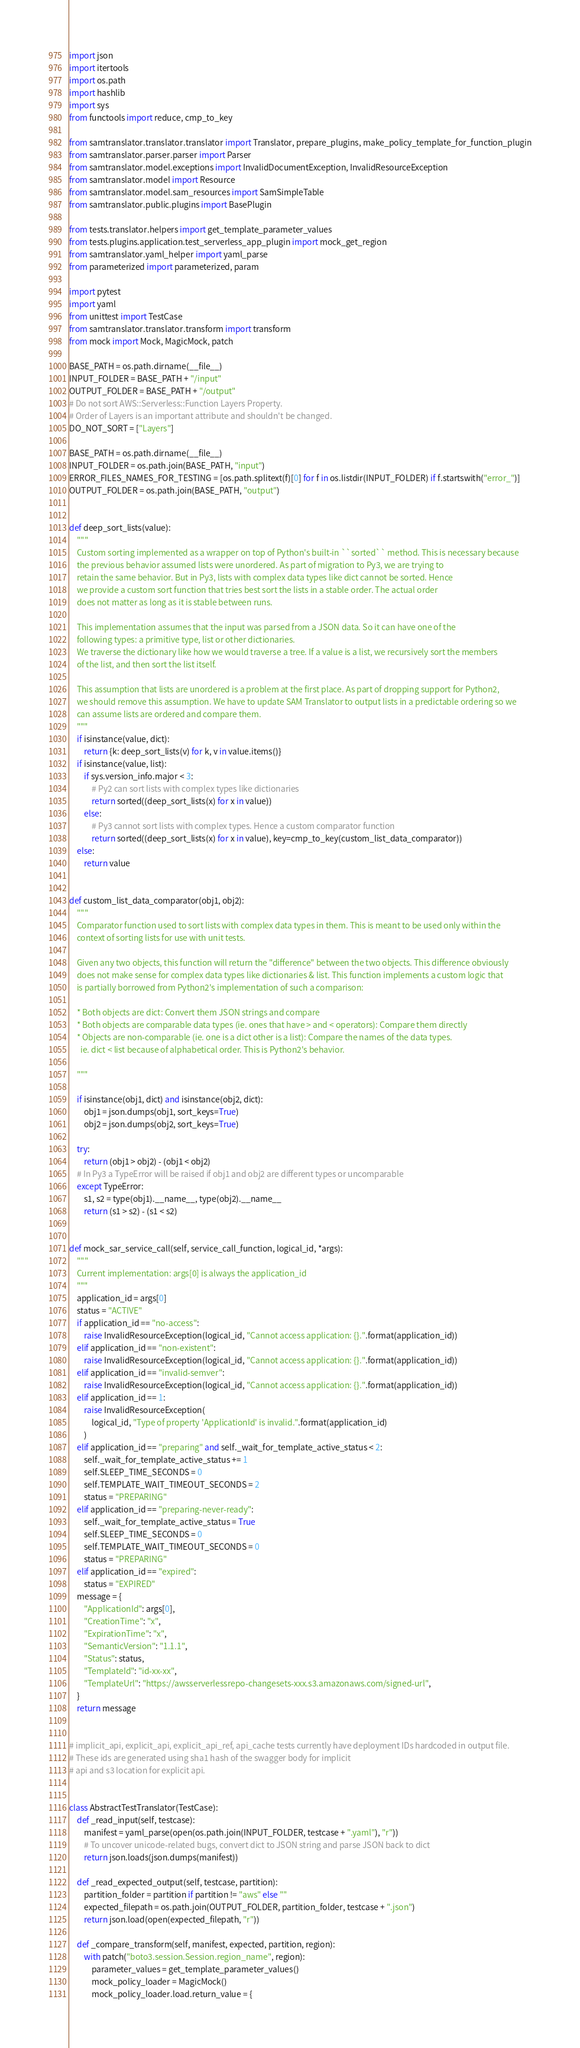<code> <loc_0><loc_0><loc_500><loc_500><_Python_>import json
import itertools
import os.path
import hashlib
import sys
from functools import reduce, cmp_to_key

from samtranslator.translator.translator import Translator, prepare_plugins, make_policy_template_for_function_plugin
from samtranslator.parser.parser import Parser
from samtranslator.model.exceptions import InvalidDocumentException, InvalidResourceException
from samtranslator.model import Resource
from samtranslator.model.sam_resources import SamSimpleTable
from samtranslator.public.plugins import BasePlugin

from tests.translator.helpers import get_template_parameter_values
from tests.plugins.application.test_serverless_app_plugin import mock_get_region
from samtranslator.yaml_helper import yaml_parse
from parameterized import parameterized, param

import pytest
import yaml
from unittest import TestCase
from samtranslator.translator.transform import transform
from mock import Mock, MagicMock, patch

BASE_PATH = os.path.dirname(__file__)
INPUT_FOLDER = BASE_PATH + "/input"
OUTPUT_FOLDER = BASE_PATH + "/output"
# Do not sort AWS::Serverless::Function Layers Property.
# Order of Layers is an important attribute and shouldn't be changed.
DO_NOT_SORT = ["Layers"]

BASE_PATH = os.path.dirname(__file__)
INPUT_FOLDER = os.path.join(BASE_PATH, "input")
ERROR_FILES_NAMES_FOR_TESTING = [os.path.splitext(f)[0] for f in os.listdir(INPUT_FOLDER) if f.startswith("error_")]
OUTPUT_FOLDER = os.path.join(BASE_PATH, "output")


def deep_sort_lists(value):
    """
    Custom sorting implemented as a wrapper on top of Python's built-in ``sorted`` method. This is necessary because
    the previous behavior assumed lists were unordered. As part of migration to Py3, we are trying to
    retain the same behavior. But in Py3, lists with complex data types like dict cannot be sorted. Hence
    we provide a custom sort function that tries best sort the lists in a stable order. The actual order
    does not matter as long as it is stable between runs.

    This implementation assumes that the input was parsed from a JSON data. So it can have one of the
    following types: a primitive type, list or other dictionaries.
    We traverse the dictionary like how we would traverse a tree. If a value is a list, we recursively sort the members
    of the list, and then sort the list itself.

    This assumption that lists are unordered is a problem at the first place. As part of dropping support for Python2,
    we should remove this assumption. We have to update SAM Translator to output lists in a predictable ordering so we
    can assume lists are ordered and compare them.
    """
    if isinstance(value, dict):
        return {k: deep_sort_lists(v) for k, v in value.items()}
    if isinstance(value, list):
        if sys.version_info.major < 3:
            # Py2 can sort lists with complex types like dictionaries
            return sorted((deep_sort_lists(x) for x in value))
        else:
            # Py3 cannot sort lists with complex types. Hence a custom comparator function
            return sorted((deep_sort_lists(x) for x in value), key=cmp_to_key(custom_list_data_comparator))
    else:
        return value


def custom_list_data_comparator(obj1, obj2):
    """
    Comparator function used to sort lists with complex data types in them. This is meant to be used only within the
    context of sorting lists for use with unit tests.

    Given any two objects, this function will return the "difference" between the two objects. This difference obviously
    does not make sense for complex data types like dictionaries & list. This function implements a custom logic that
    is partially borrowed from Python2's implementation of such a comparison:

    * Both objects are dict: Convert them JSON strings and compare
    * Both objects are comparable data types (ie. ones that have > and < operators): Compare them directly
    * Objects are non-comparable (ie. one is a dict other is a list): Compare the names of the data types.
      ie. dict < list because of alphabetical order. This is Python2's behavior.

    """

    if isinstance(obj1, dict) and isinstance(obj2, dict):
        obj1 = json.dumps(obj1, sort_keys=True)
        obj2 = json.dumps(obj2, sort_keys=True)

    try:
        return (obj1 > obj2) - (obj1 < obj2)
    # In Py3 a TypeError will be raised if obj1 and obj2 are different types or uncomparable
    except TypeError:
        s1, s2 = type(obj1).__name__, type(obj2).__name__
        return (s1 > s2) - (s1 < s2)


def mock_sar_service_call(self, service_call_function, logical_id, *args):
    """
    Current implementation: args[0] is always the application_id
    """
    application_id = args[0]
    status = "ACTIVE"
    if application_id == "no-access":
        raise InvalidResourceException(logical_id, "Cannot access application: {}.".format(application_id))
    elif application_id == "non-existent":
        raise InvalidResourceException(logical_id, "Cannot access application: {}.".format(application_id))
    elif application_id == "invalid-semver":
        raise InvalidResourceException(logical_id, "Cannot access application: {}.".format(application_id))
    elif application_id == 1:
        raise InvalidResourceException(
            logical_id, "Type of property 'ApplicationId' is invalid.".format(application_id)
        )
    elif application_id == "preparing" and self._wait_for_template_active_status < 2:
        self._wait_for_template_active_status += 1
        self.SLEEP_TIME_SECONDS = 0
        self.TEMPLATE_WAIT_TIMEOUT_SECONDS = 2
        status = "PREPARING"
    elif application_id == "preparing-never-ready":
        self._wait_for_template_active_status = True
        self.SLEEP_TIME_SECONDS = 0
        self.TEMPLATE_WAIT_TIMEOUT_SECONDS = 0
        status = "PREPARING"
    elif application_id == "expired":
        status = "EXPIRED"
    message = {
        "ApplicationId": args[0],
        "CreationTime": "x",
        "ExpirationTime": "x",
        "SemanticVersion": "1.1.1",
        "Status": status,
        "TemplateId": "id-xx-xx",
        "TemplateUrl": "https://awsserverlessrepo-changesets-xxx.s3.amazonaws.com/signed-url",
    }
    return message


# implicit_api, explicit_api, explicit_api_ref, api_cache tests currently have deployment IDs hardcoded in output file.
# These ids are generated using sha1 hash of the swagger body for implicit
# api and s3 location for explicit api.


class AbstractTestTranslator(TestCase):
    def _read_input(self, testcase):
        manifest = yaml_parse(open(os.path.join(INPUT_FOLDER, testcase + ".yaml"), "r"))
        # To uncover unicode-related bugs, convert dict to JSON string and parse JSON back to dict
        return json.loads(json.dumps(manifest))

    def _read_expected_output(self, testcase, partition):
        partition_folder = partition if partition != "aws" else ""
        expected_filepath = os.path.join(OUTPUT_FOLDER, partition_folder, testcase + ".json")
        return json.load(open(expected_filepath, "r"))

    def _compare_transform(self, manifest, expected, partition, region):
        with patch("boto3.session.Session.region_name", region):
            parameter_values = get_template_parameter_values()
            mock_policy_loader = MagicMock()
            mock_policy_loader.load.return_value = {</code> 